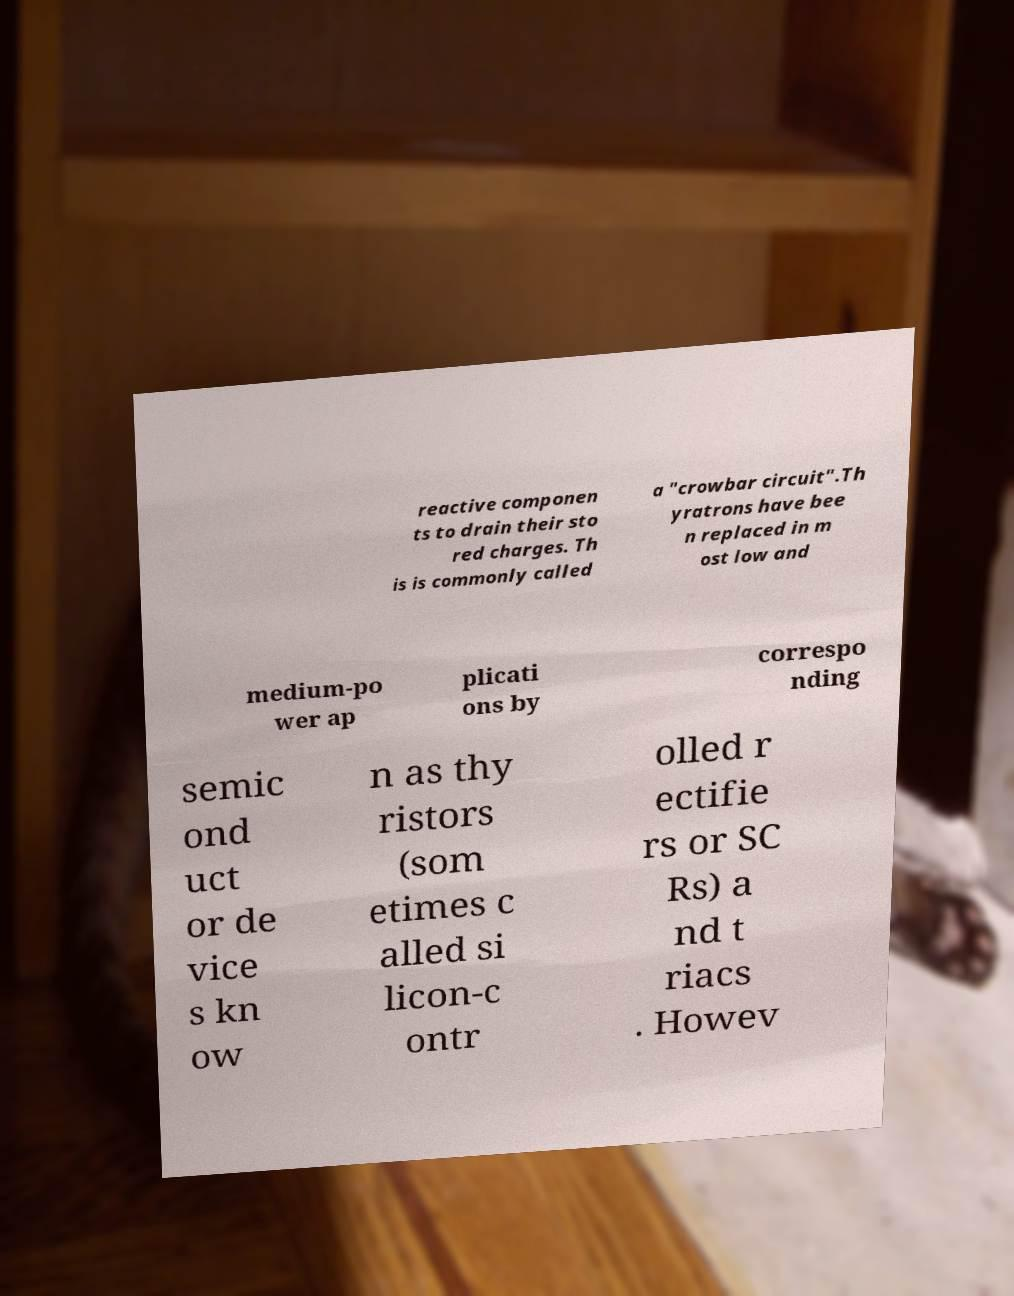I need the written content from this picture converted into text. Can you do that? reactive componen ts to drain their sto red charges. Th is is commonly called a "crowbar circuit".Th yratrons have bee n replaced in m ost low and medium-po wer ap plicati ons by correspo nding semic ond uct or de vice s kn ow n as thy ristors (som etimes c alled si licon-c ontr olled r ectifie rs or SC Rs) a nd t riacs . Howev 